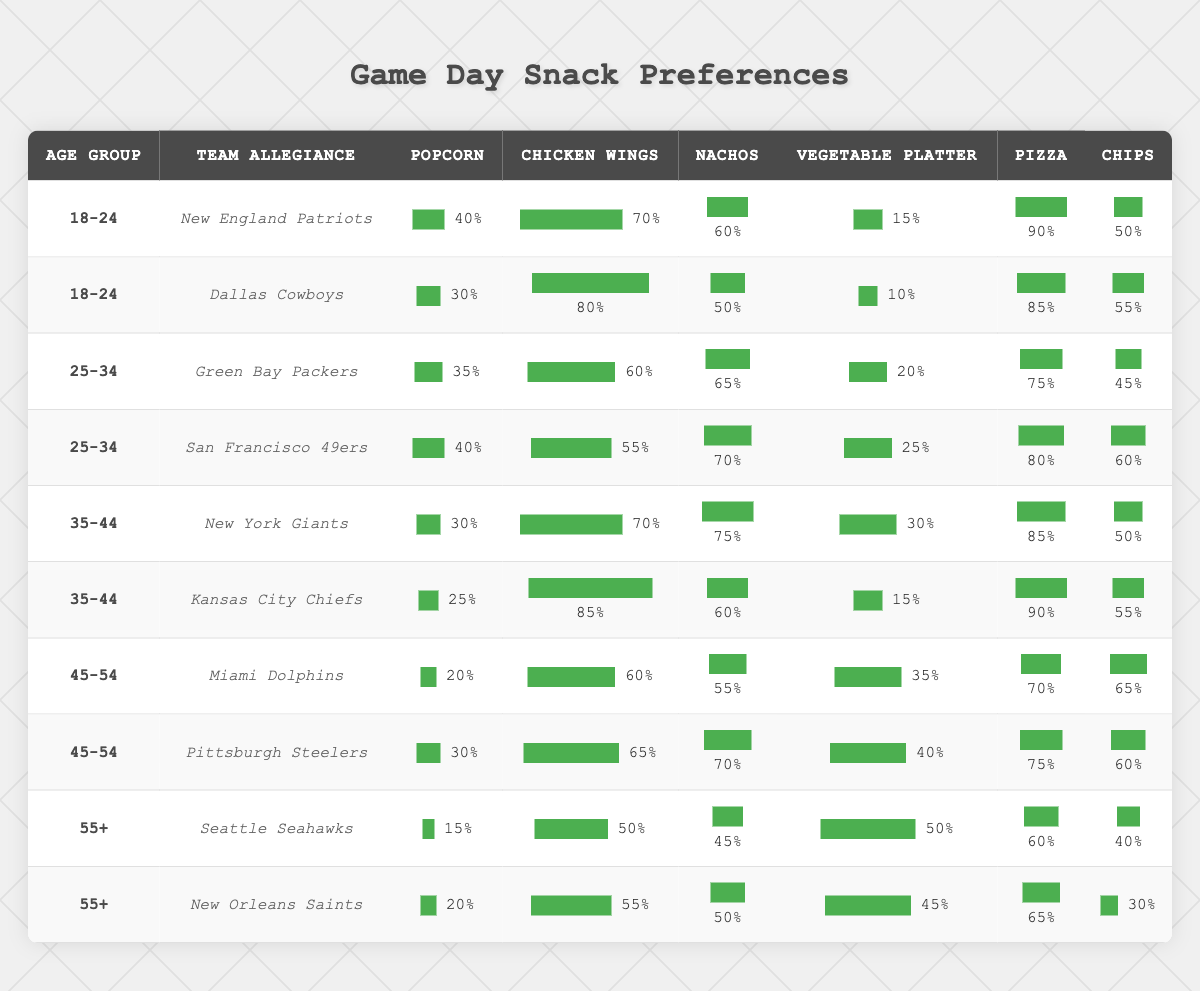What is the most popular snack among 18-24 year olds who support the New England Patriots? Looking at the row for the 18-24 age group and New England Patriots, the percentages for each snack show that pizza has the highest preference at 90%.
Answer: Pizza Which team has the highest preference for chicken wings among the age group 35-44? Within the 35-44 age group, the Kansas City Chiefs have a chicken wing preference of 85%, which is higher than the New York Giants' 70%.
Answer: Kansas City Chiefs Which snack is least preferred by the 45-54 age group supporting the Pittsburgh Steelers? For the age group 45-54 and supporting the Pittsburgh Steelers, the snack with the lowest preference is popcorn at 30%.
Answer: Popcorn What percentage of 25-34 year olds who support San Francisco 49ers prefer nachos? Looking at the San Francisco 49ers row under the 25-34 age group, nachos have a preference of 70%.
Answer: 70% Do more 55+ age group members prefer chips or vegetable platter when supporting the Seattle Seahawks? In the 55+ age group supporting the Seattle Seahawks, chips are preferred at 40% over vegetable platter at 50%. This means vegetable platter is preferred more.
Answer: No What is the average preference for popcorn among all teams in the 18-24 age group? The popcorn preferences for the 18-24 age group are 40% (Patriots) and 30% (Cowboys). Adding them gives 70%, and dividing by 2 gives an average of 35%.
Answer: 35% Which age group shows the highest preference for pizza overall? By reviewing all rows, the highest pizza preference is 90% from the 35-44 age group supporting the Kansas City Chiefs, which is higher than any other age group.
Answer: 35-44 How does the chicken wings preference for Miami Dolphins in the 45-54 age group compare with that of Kansas City Chiefs in the 35-44 age group? Miami Dolphins in 45-54 have a chicken wings preference of 60%, while Kansas City Chiefs in 35-44 have 85%. Comparing these shows that Kansas City Chiefs have a higher preference.
Answer: Kansas City Chiefs Which team in the 55+ category has the highest overall snack preference? For the 55+ age group, the overall snack preferences show that both the Seattle Seahawks and New Orleans Saints have different preferences, with the Saints generally slightly higher in pizza and chicken wings. However, no single team stands out overall.
Answer: None What is the total percentage of chicken wings preferences from the 25-34 age group? For the 25-34 age group, the preferences for chicken wings are 60% (Packers) and 55% (49ers). Summing these gives a total of 115% for chicken wings in this age group.
Answer: 115% 